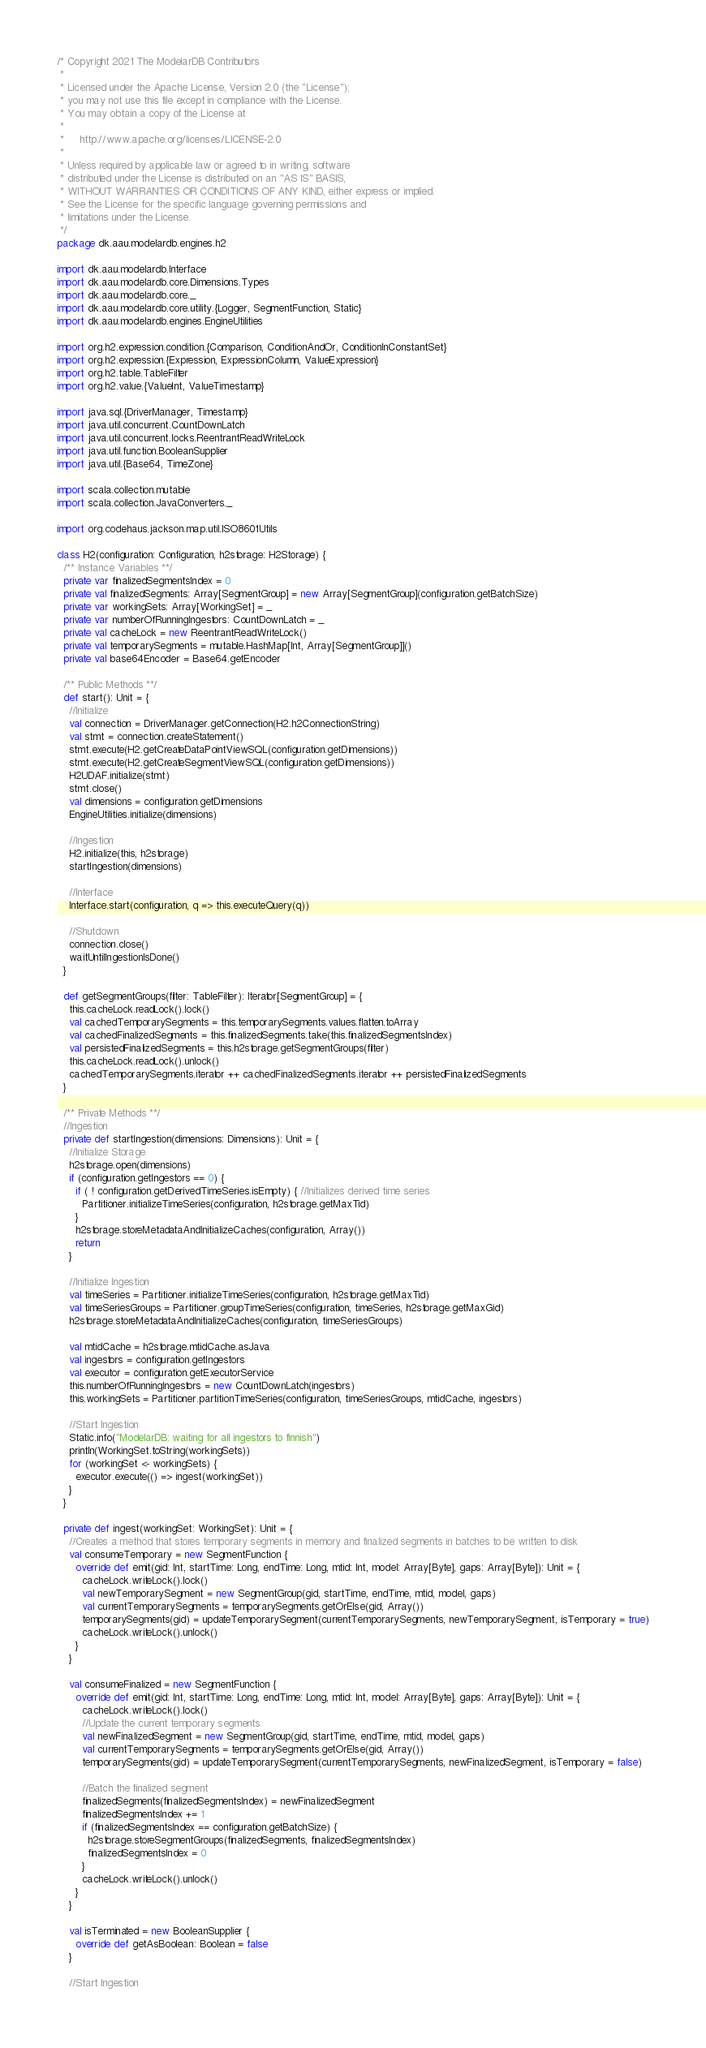<code> <loc_0><loc_0><loc_500><loc_500><_Scala_>/* Copyright 2021 The ModelarDB Contributors
 *
 * Licensed under the Apache License, Version 2.0 (the "License");
 * you may not use this file except in compliance with the License.
 * You may obtain a copy of the License at
 *
 *     http://www.apache.org/licenses/LICENSE-2.0
 *
 * Unless required by applicable law or agreed to in writing, software
 * distributed under the License is distributed on an "AS IS" BASIS,
 * WITHOUT WARRANTIES OR CONDITIONS OF ANY KIND, either express or implied.
 * See the License for the specific language governing permissions and
 * limitations under the License.
 */
package dk.aau.modelardb.engines.h2

import dk.aau.modelardb.Interface
import dk.aau.modelardb.core.Dimensions.Types
import dk.aau.modelardb.core._
import dk.aau.modelardb.core.utility.{Logger, SegmentFunction, Static}
import dk.aau.modelardb.engines.EngineUtilities

import org.h2.expression.condition.{Comparison, ConditionAndOr, ConditionInConstantSet}
import org.h2.expression.{Expression, ExpressionColumn, ValueExpression}
import org.h2.table.TableFilter
import org.h2.value.{ValueInt, ValueTimestamp}

import java.sql.{DriverManager, Timestamp}
import java.util.concurrent.CountDownLatch
import java.util.concurrent.locks.ReentrantReadWriteLock
import java.util.function.BooleanSupplier
import java.util.{Base64, TimeZone}

import scala.collection.mutable
import scala.collection.JavaConverters._

import org.codehaus.jackson.map.util.ISO8601Utils

class H2(configuration: Configuration, h2storage: H2Storage) {
  /** Instance Variables **/
  private var finalizedSegmentsIndex = 0
  private val finalizedSegments: Array[SegmentGroup] = new Array[SegmentGroup](configuration.getBatchSize)
  private var workingSets: Array[WorkingSet] = _
  private var numberOfRunningIngestors: CountDownLatch = _
  private val cacheLock = new ReentrantReadWriteLock()
  private val temporarySegments = mutable.HashMap[Int, Array[SegmentGroup]]()
  private val base64Encoder = Base64.getEncoder

  /** Public Methods **/
  def start(): Unit = {
    //Initialize
    val connection = DriverManager.getConnection(H2.h2ConnectionString)
    val stmt = connection.createStatement()
    stmt.execute(H2.getCreateDataPointViewSQL(configuration.getDimensions))
    stmt.execute(H2.getCreateSegmentViewSQL(configuration.getDimensions))
    H2UDAF.initialize(stmt)
    stmt.close()
    val dimensions = configuration.getDimensions
    EngineUtilities.initialize(dimensions)

    //Ingestion
    H2.initialize(this, h2storage)
    startIngestion(dimensions)

    //Interface
    Interface.start(configuration, q => this.executeQuery(q))

    //Shutdown
    connection.close()
    waitUntilIngestionIsDone()
  }

  def getSegmentGroups(filter: TableFilter): Iterator[SegmentGroup] = {
    this.cacheLock.readLock().lock()
    val cachedTemporarySegments = this.temporarySegments.values.flatten.toArray
    val cachedFinalizedSegments = this.finalizedSegments.take(this.finalizedSegmentsIndex)
    val persistedFinalizedSegments = this.h2storage.getSegmentGroups(filter)
    this.cacheLock.readLock().unlock()
    cachedTemporarySegments.iterator ++ cachedFinalizedSegments.iterator ++ persistedFinalizedSegments
  }

  /** Private Methods **/
  //Ingestion
  private def startIngestion(dimensions: Dimensions): Unit = {
    //Initialize Storage
    h2storage.open(dimensions)
    if (configuration.getIngestors == 0) {
      if ( ! configuration.getDerivedTimeSeries.isEmpty) { //Initializes derived time series
        Partitioner.initializeTimeSeries(configuration, h2storage.getMaxTid)
      }
      h2storage.storeMetadataAndInitializeCaches(configuration, Array())
      return
    }

    //Initialize Ingestion
    val timeSeries = Partitioner.initializeTimeSeries(configuration, h2storage.getMaxTid)
    val timeSeriesGroups = Partitioner.groupTimeSeries(configuration, timeSeries, h2storage.getMaxGid)
    h2storage.storeMetadataAndInitializeCaches(configuration, timeSeriesGroups)

    val mtidCache = h2storage.mtidCache.asJava
    val ingestors = configuration.getIngestors
    val executor = configuration.getExecutorService
    this.numberOfRunningIngestors = new CountDownLatch(ingestors)
    this.workingSets = Partitioner.partitionTimeSeries(configuration, timeSeriesGroups, mtidCache, ingestors)

    //Start Ingestion
    Static.info("ModelarDB: waiting for all ingestors to finnish")
    println(WorkingSet.toString(workingSets))
    for (workingSet <- workingSets) {
      executor.execute(() => ingest(workingSet))
    }
  }

  private def ingest(workingSet: WorkingSet): Unit = {
    //Creates a method that stores temporary segments in memory and finalized segments in batches to be written to disk
    val consumeTemporary = new SegmentFunction {
      override def emit(gid: Int, startTime: Long, endTime: Long, mtid: Int, model: Array[Byte], gaps: Array[Byte]): Unit = {
        cacheLock.writeLock().lock()
        val newTemporarySegment = new SegmentGroup(gid, startTime, endTime, mtid, model, gaps)
        val currentTemporarySegments = temporarySegments.getOrElse(gid, Array())
        temporarySegments(gid) = updateTemporarySegment(currentTemporarySegments, newTemporarySegment, isTemporary = true)
        cacheLock.writeLock().unlock()
      }
    }

    val consumeFinalized = new SegmentFunction {
      override def emit(gid: Int, startTime: Long, endTime: Long, mtid: Int, model: Array[Byte], gaps: Array[Byte]): Unit = {
        cacheLock.writeLock().lock()
        //Update the current temporary segments
        val newFinalizedSegment = new SegmentGroup(gid, startTime, endTime, mtid, model, gaps)
        val currentTemporarySegments = temporarySegments.getOrElse(gid, Array())
        temporarySegments(gid) = updateTemporarySegment(currentTemporarySegments, newFinalizedSegment, isTemporary = false)

        //Batch the finalized segment
        finalizedSegments(finalizedSegmentsIndex) = newFinalizedSegment
        finalizedSegmentsIndex += 1
        if (finalizedSegmentsIndex == configuration.getBatchSize) {
          h2storage.storeSegmentGroups(finalizedSegments, finalizedSegmentsIndex)
          finalizedSegmentsIndex = 0
        }
        cacheLock.writeLock().unlock()
      }
    }

    val isTerminated = new BooleanSupplier {
      override def getAsBoolean: Boolean = false
    }

    //Start Ingestion</code> 